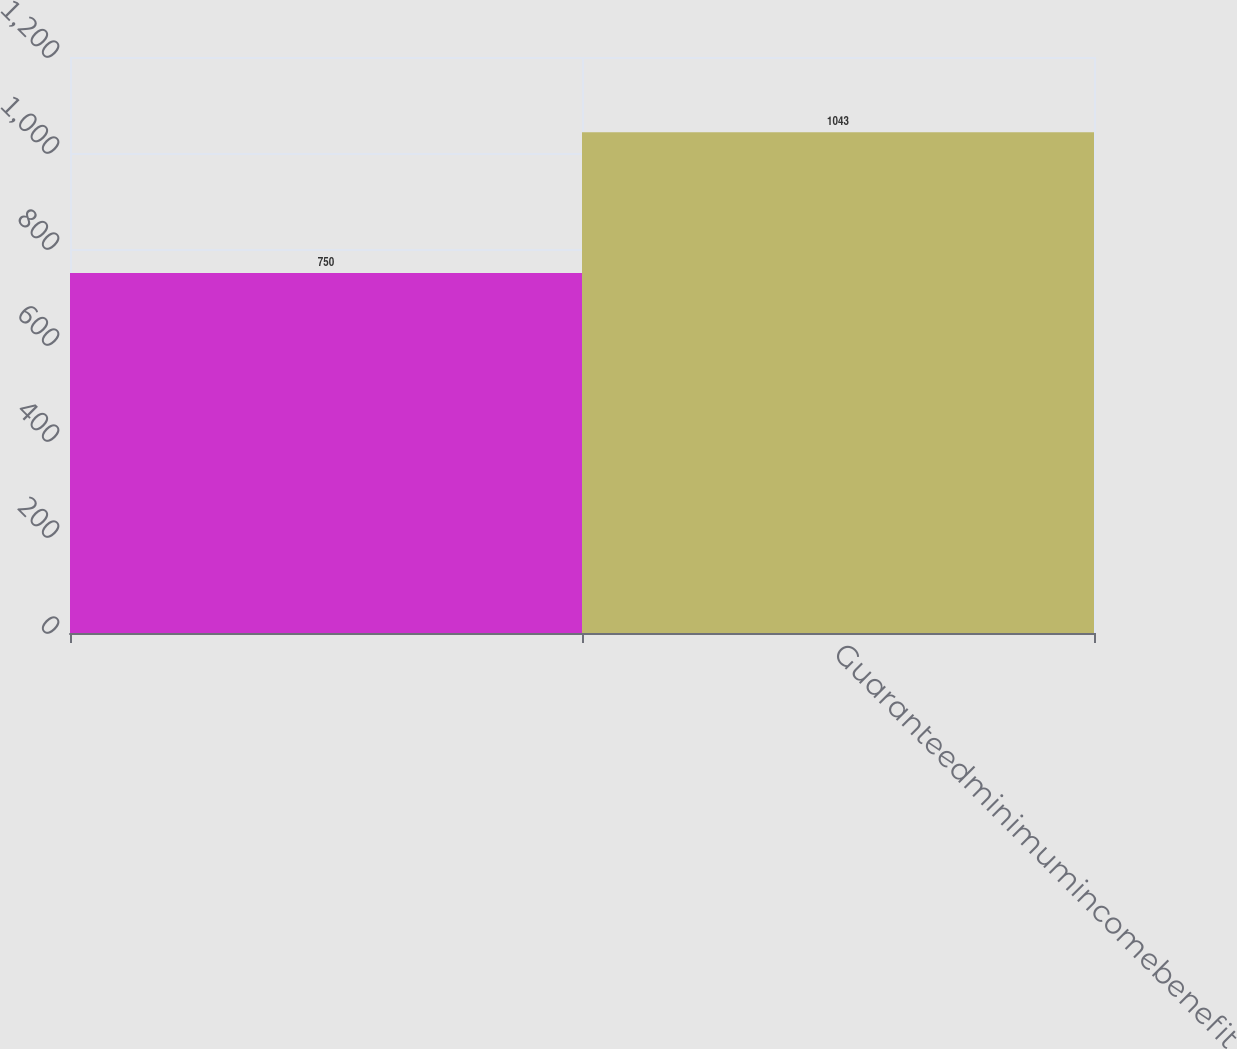Convert chart. <chart><loc_0><loc_0><loc_500><loc_500><bar_chart><ecel><fcel>Guaranteedminimumincomebenefit<nl><fcel>750<fcel>1043<nl></chart> 